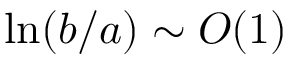<formula> <loc_0><loc_0><loc_500><loc_500>\ln ( b / a ) \sim O ( 1 )</formula> 